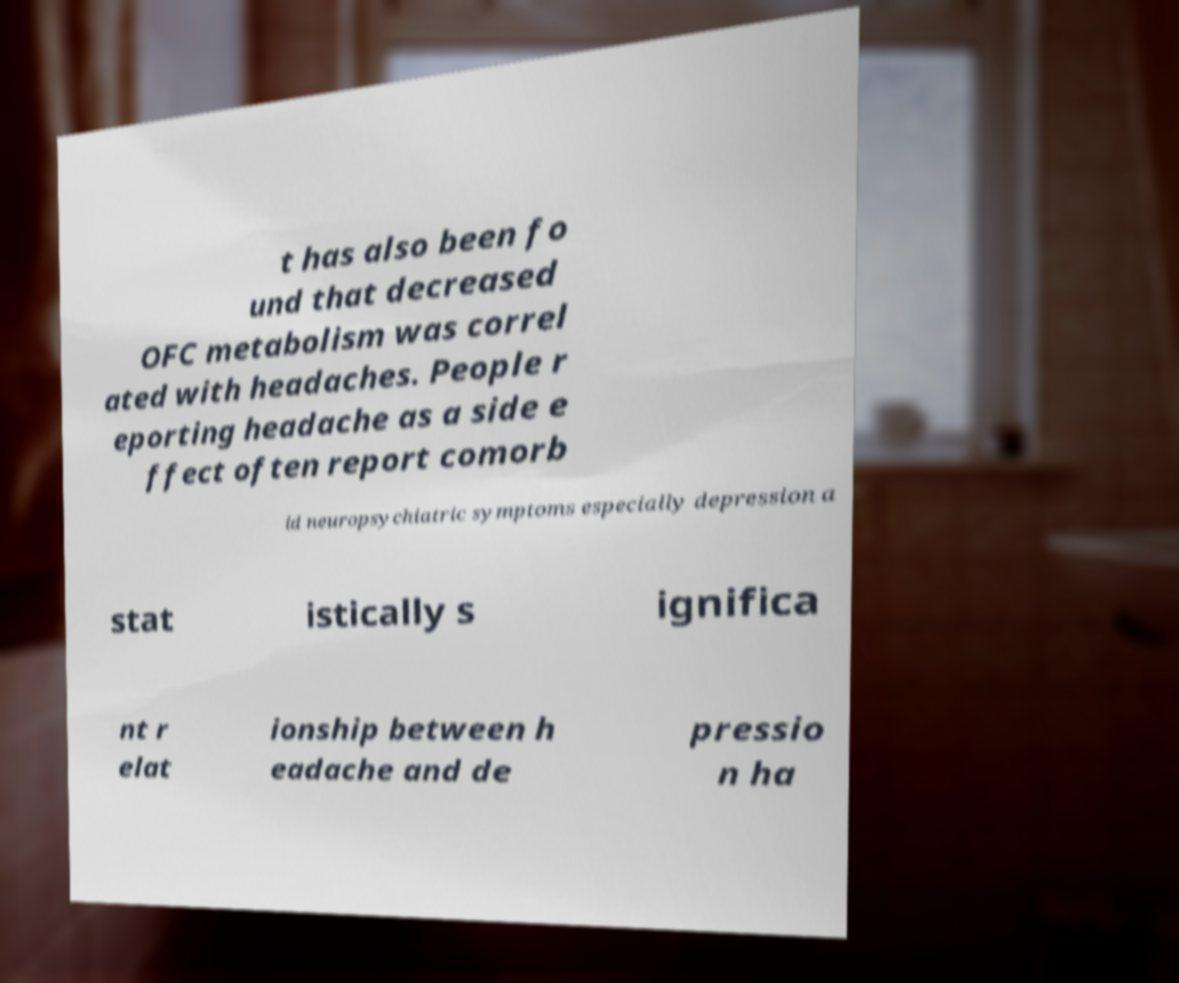Please read and relay the text visible in this image. What does it say? t has also been fo und that decreased OFC metabolism was correl ated with headaches. People r eporting headache as a side e ffect often report comorb id neuropsychiatric symptoms especially depression a stat istically s ignifica nt r elat ionship between h eadache and de pressio n ha 